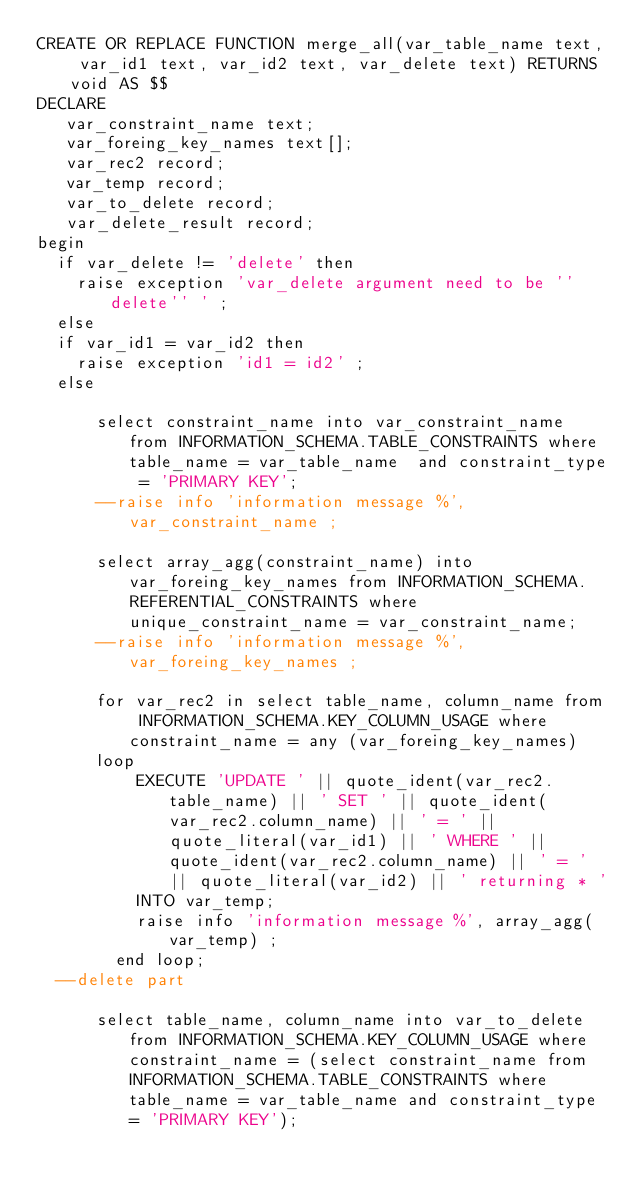<code> <loc_0><loc_0><loc_500><loc_500><_SQL_>CREATE OR REPLACE FUNCTION merge_all(var_table_name text, var_id1 text, var_id2 text, var_delete text) RETURNS void AS $$
DECLARE
   var_constraint_name text;
   var_foreing_key_names text[];
   var_rec2 record;
   var_temp record;
   var_to_delete record;
   var_delete_result record;
begin
	if var_delete != 'delete' then
		raise exception 'var_delete argument need to be ''delete'' ' ;
	else
	if var_id1 = var_id2 then
		raise exception 'id1 = id2' ;
	else 

    	select constraint_name into var_constraint_name from INFORMATION_SCHEMA.TABLE_CONSTRAINTS where table_name = var_table_name  and constraint_type = 'PRIMARY KEY';
  		--raise info 'information message %', var_constraint_name ;
  
  		select array_agg(constraint_name) into var_foreing_key_names from INFORMATION_SCHEMA.REFERENTIAL_CONSTRAINTS where unique_constraint_name = var_constraint_name;
  		--raise info 'information message %',  var_foreing_key_names ;

     	for var_rec2 in select table_name, column_name from INFORMATION_SCHEMA.KEY_COLUMN_USAGE where constraint_name = any (var_foreing_key_names)
 			loop 
  				EXECUTE 'UPDATE ' || quote_ident(var_rec2.table_name) || ' SET ' || quote_ident(var_rec2.column_name) || ' = ' || quote_literal(var_id1) || ' WHERE ' || quote_ident(var_rec2.column_name) || ' = ' || quote_literal(var_id2) || ' returning * ' 
    			INTO var_temp;
    			raise info 'information message %', array_agg(var_temp) ;
  			end loop;
	--delete part
  		
  		select table_name, column_name into var_to_delete from INFORMATION_SCHEMA.KEY_COLUMN_USAGE where constraint_name = (select constraint_name from INFORMATION_SCHEMA.TABLE_CONSTRAINTS where table_name = var_table_name and constraint_type = 'PRIMARY KEY');</code> 